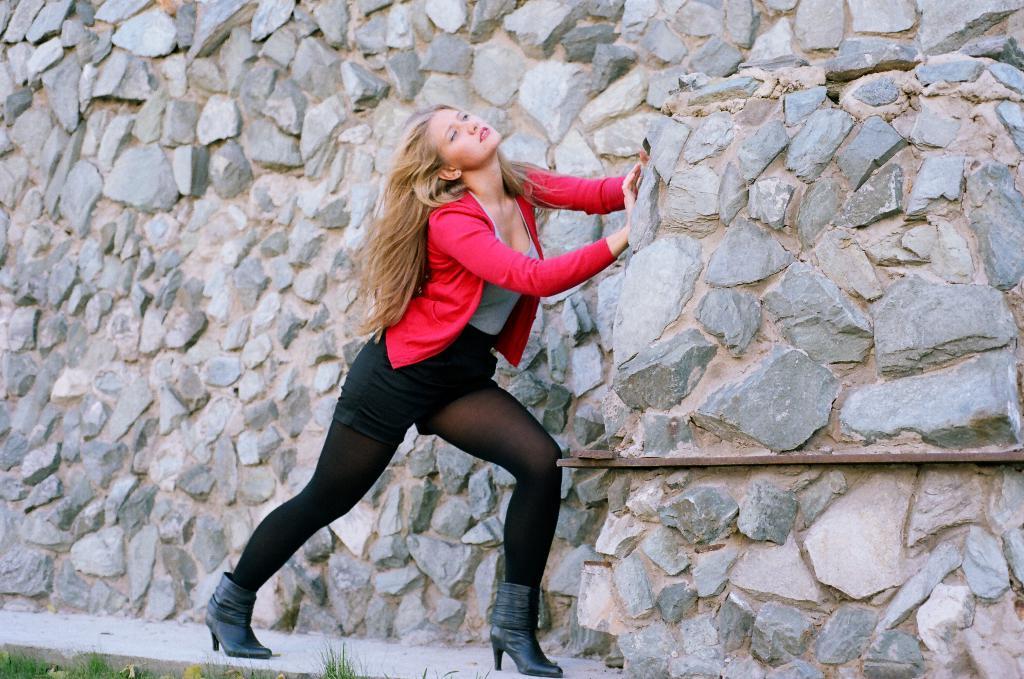Can you describe this image briefly? In this image there is a person standing, there is the grass truncated towards the bottom of the image, there is a wall truncated. 